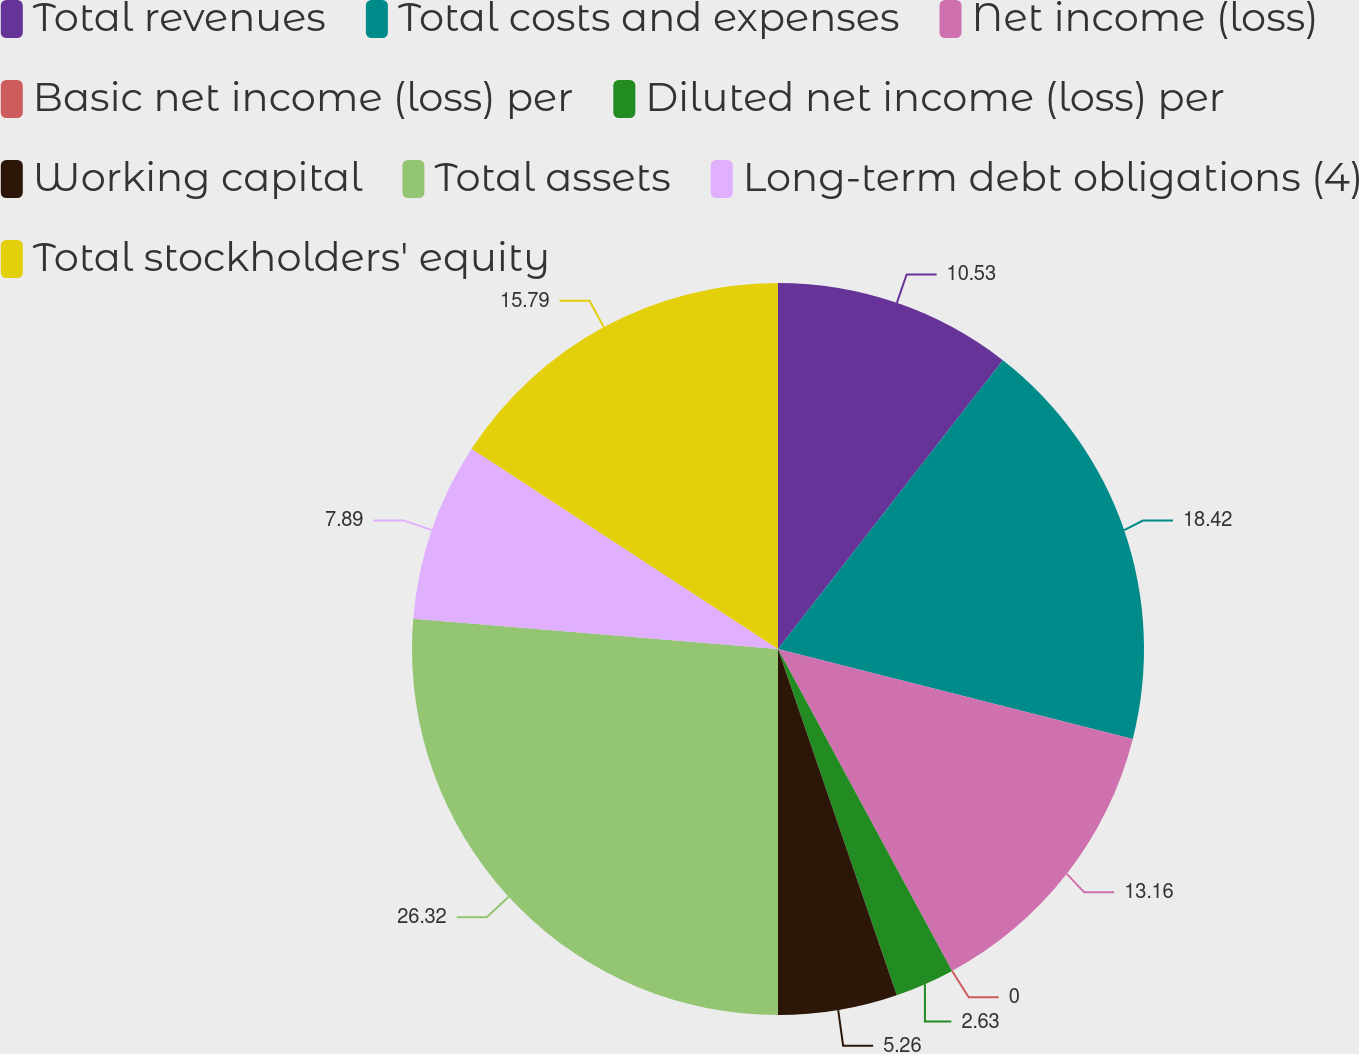<chart> <loc_0><loc_0><loc_500><loc_500><pie_chart><fcel>Total revenues<fcel>Total costs and expenses<fcel>Net income (loss)<fcel>Basic net income (loss) per<fcel>Diluted net income (loss) per<fcel>Working capital<fcel>Total assets<fcel>Long-term debt obligations (4)<fcel>Total stockholders' equity<nl><fcel>10.53%<fcel>18.42%<fcel>13.16%<fcel>0.0%<fcel>2.63%<fcel>5.26%<fcel>26.32%<fcel>7.89%<fcel>15.79%<nl></chart> 